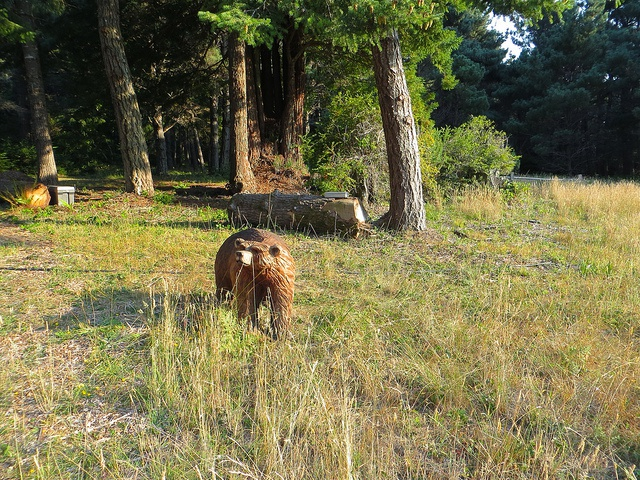Describe the objects in this image and their specific colors. I can see a bear in black, maroon, and tan tones in this image. 